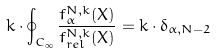Convert formula to latex. <formula><loc_0><loc_0><loc_500><loc_500>k \cdot \oint _ { C _ { \infty } } \frac { f ^ { N , k } _ { \alpha } ( X ) } { f ^ { N , k } _ { r e l } ( X ) } = k \cdot \delta _ { \alpha , N - 2 }</formula> 